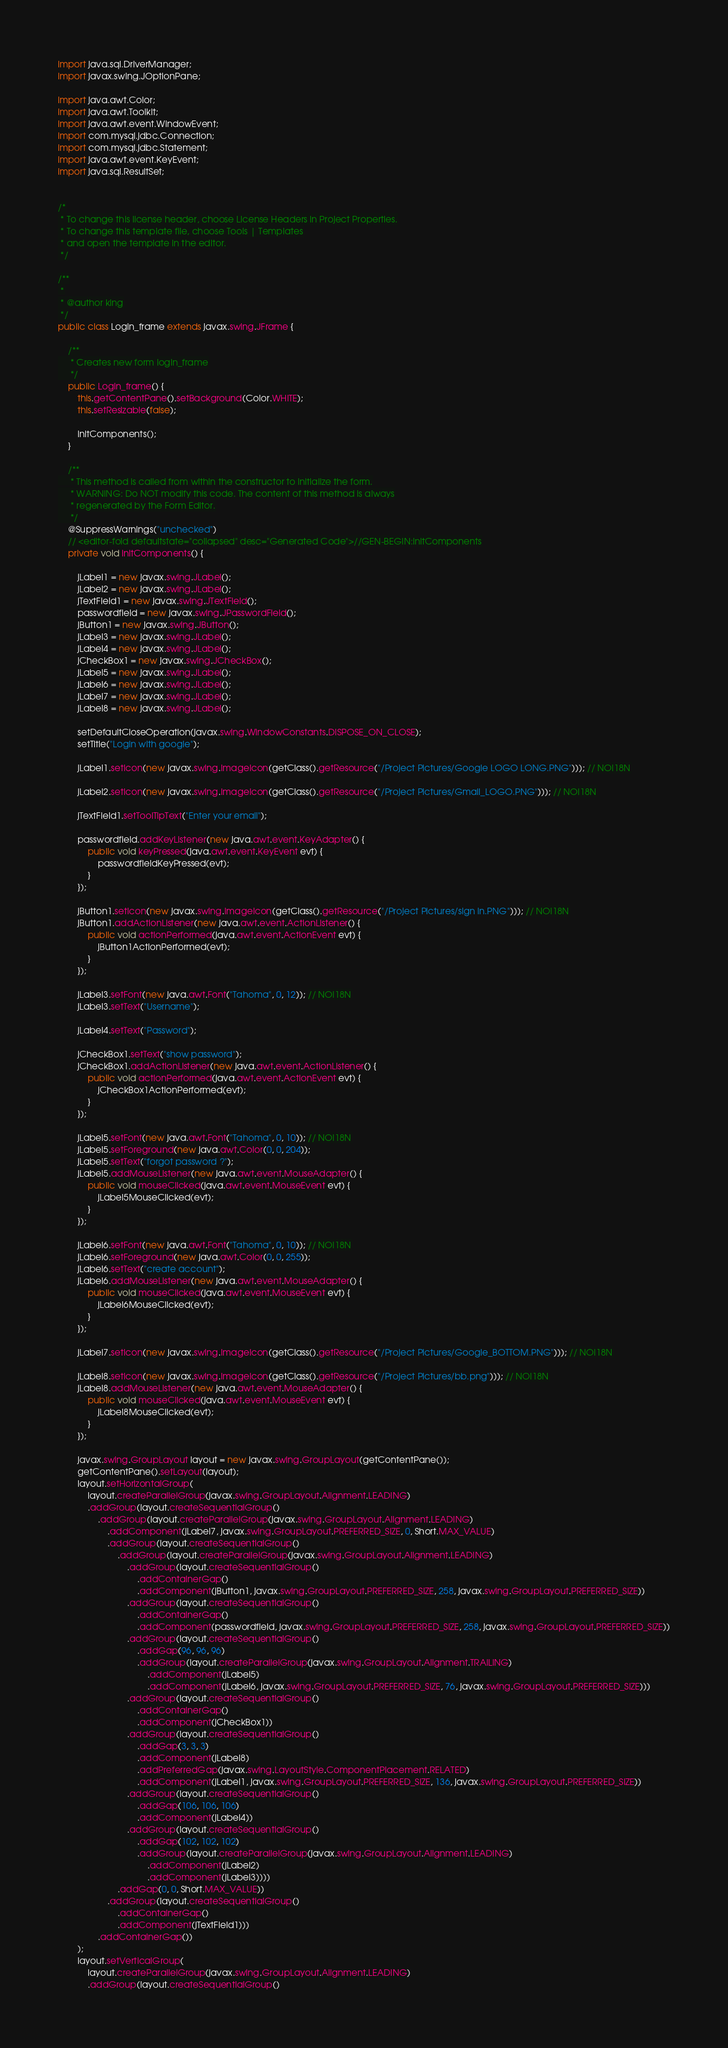<code> <loc_0><loc_0><loc_500><loc_500><_Java_>import java.sql.DriverManager;
import javax.swing.JOptionPane;

import java.awt.Color;
import java.awt.Toolkit;
import java.awt.event.WindowEvent;
import com.mysql.jdbc.Connection;
import com.mysql.jdbc.Statement;
import java.awt.event.KeyEvent;
import java.sql.ResultSet;


/*
 * To change this license header, choose License Headers in Project Properties.
 * To change this template file, choose Tools | Templates
 * and open the template in the editor.
 */

/**
 *
 * @author king
 */
public class Login_frame extends javax.swing.JFrame {

    /**
     * Creates new form login_frame
     */
    public Login_frame() {
        this.getContentPane().setBackground(Color.WHITE);
        this.setResizable(false);
        
        initComponents();
    }

    /**
     * This method is called from within the constructor to initialize the form.
     * WARNING: Do NOT modify this code. The content of this method is always
     * regenerated by the Form Editor.
     */
    @SuppressWarnings("unchecked")
    // <editor-fold defaultstate="collapsed" desc="Generated Code">//GEN-BEGIN:initComponents
    private void initComponents() {

        jLabel1 = new javax.swing.JLabel();
        jLabel2 = new javax.swing.JLabel();
        jTextField1 = new javax.swing.JTextField();
        passwordfield = new javax.swing.JPasswordField();
        jButton1 = new javax.swing.JButton();
        jLabel3 = new javax.swing.JLabel();
        jLabel4 = new javax.swing.JLabel();
        jCheckBox1 = new javax.swing.JCheckBox();
        jLabel5 = new javax.swing.JLabel();
        jLabel6 = new javax.swing.JLabel();
        jLabel7 = new javax.swing.JLabel();
        jLabel8 = new javax.swing.JLabel();

        setDefaultCloseOperation(javax.swing.WindowConstants.DISPOSE_ON_CLOSE);
        setTitle("Login with google");

        jLabel1.setIcon(new javax.swing.ImageIcon(getClass().getResource("/Project Pictures/Google LOGO LONG.PNG"))); // NOI18N

        jLabel2.setIcon(new javax.swing.ImageIcon(getClass().getResource("/Project Pictures/Gmail_LOGO.PNG"))); // NOI18N

        jTextField1.setToolTipText("Enter your email");

        passwordfield.addKeyListener(new java.awt.event.KeyAdapter() {
            public void keyPressed(java.awt.event.KeyEvent evt) {
                passwordfieldKeyPressed(evt);
            }
        });

        jButton1.setIcon(new javax.swing.ImageIcon(getClass().getResource("/Project Pictures/sign in.PNG"))); // NOI18N
        jButton1.addActionListener(new java.awt.event.ActionListener() {
            public void actionPerformed(java.awt.event.ActionEvent evt) {
                jButton1ActionPerformed(evt);
            }
        });

        jLabel3.setFont(new java.awt.Font("Tahoma", 0, 12)); // NOI18N
        jLabel3.setText("Username");

        jLabel4.setText("Password");

        jCheckBox1.setText("show password");
        jCheckBox1.addActionListener(new java.awt.event.ActionListener() {
            public void actionPerformed(java.awt.event.ActionEvent evt) {
                jCheckBox1ActionPerformed(evt);
            }
        });

        jLabel5.setFont(new java.awt.Font("Tahoma", 0, 10)); // NOI18N
        jLabel5.setForeground(new java.awt.Color(0, 0, 204));
        jLabel5.setText("forgot password ?");
        jLabel5.addMouseListener(new java.awt.event.MouseAdapter() {
            public void mouseClicked(java.awt.event.MouseEvent evt) {
                jLabel5MouseClicked(evt);
            }
        });

        jLabel6.setFont(new java.awt.Font("Tahoma", 0, 10)); // NOI18N
        jLabel6.setForeground(new java.awt.Color(0, 0, 255));
        jLabel6.setText("create account");
        jLabel6.addMouseListener(new java.awt.event.MouseAdapter() {
            public void mouseClicked(java.awt.event.MouseEvent evt) {
                jLabel6MouseClicked(evt);
            }
        });

        jLabel7.setIcon(new javax.swing.ImageIcon(getClass().getResource("/Project Pictures/Google_BOTTOM.PNG"))); // NOI18N

        jLabel8.setIcon(new javax.swing.ImageIcon(getClass().getResource("/Project Pictures/bb.png"))); // NOI18N
        jLabel8.addMouseListener(new java.awt.event.MouseAdapter() {
            public void mouseClicked(java.awt.event.MouseEvent evt) {
                jLabel8MouseClicked(evt);
            }
        });

        javax.swing.GroupLayout layout = new javax.swing.GroupLayout(getContentPane());
        getContentPane().setLayout(layout);
        layout.setHorizontalGroup(
            layout.createParallelGroup(javax.swing.GroupLayout.Alignment.LEADING)
            .addGroup(layout.createSequentialGroup()
                .addGroup(layout.createParallelGroup(javax.swing.GroupLayout.Alignment.LEADING)
                    .addComponent(jLabel7, javax.swing.GroupLayout.PREFERRED_SIZE, 0, Short.MAX_VALUE)
                    .addGroup(layout.createSequentialGroup()
                        .addGroup(layout.createParallelGroup(javax.swing.GroupLayout.Alignment.LEADING)
                            .addGroup(layout.createSequentialGroup()
                                .addContainerGap()
                                .addComponent(jButton1, javax.swing.GroupLayout.PREFERRED_SIZE, 258, javax.swing.GroupLayout.PREFERRED_SIZE))
                            .addGroup(layout.createSequentialGroup()
                                .addContainerGap()
                                .addComponent(passwordfield, javax.swing.GroupLayout.PREFERRED_SIZE, 258, javax.swing.GroupLayout.PREFERRED_SIZE))
                            .addGroup(layout.createSequentialGroup()
                                .addGap(96, 96, 96)
                                .addGroup(layout.createParallelGroup(javax.swing.GroupLayout.Alignment.TRAILING)
                                    .addComponent(jLabel5)
                                    .addComponent(jLabel6, javax.swing.GroupLayout.PREFERRED_SIZE, 76, javax.swing.GroupLayout.PREFERRED_SIZE)))
                            .addGroup(layout.createSequentialGroup()
                                .addContainerGap()
                                .addComponent(jCheckBox1))
                            .addGroup(layout.createSequentialGroup()
                                .addGap(3, 3, 3)
                                .addComponent(jLabel8)
                                .addPreferredGap(javax.swing.LayoutStyle.ComponentPlacement.RELATED)
                                .addComponent(jLabel1, javax.swing.GroupLayout.PREFERRED_SIZE, 136, javax.swing.GroupLayout.PREFERRED_SIZE))
                            .addGroup(layout.createSequentialGroup()
                                .addGap(106, 106, 106)
                                .addComponent(jLabel4))
                            .addGroup(layout.createSequentialGroup()
                                .addGap(102, 102, 102)
                                .addGroup(layout.createParallelGroup(javax.swing.GroupLayout.Alignment.LEADING)
                                    .addComponent(jLabel2)
                                    .addComponent(jLabel3))))
                        .addGap(0, 0, Short.MAX_VALUE))
                    .addGroup(layout.createSequentialGroup()
                        .addContainerGap()
                        .addComponent(jTextField1)))
                .addContainerGap())
        );
        layout.setVerticalGroup(
            layout.createParallelGroup(javax.swing.GroupLayout.Alignment.LEADING)
            .addGroup(layout.createSequentialGroup()</code> 